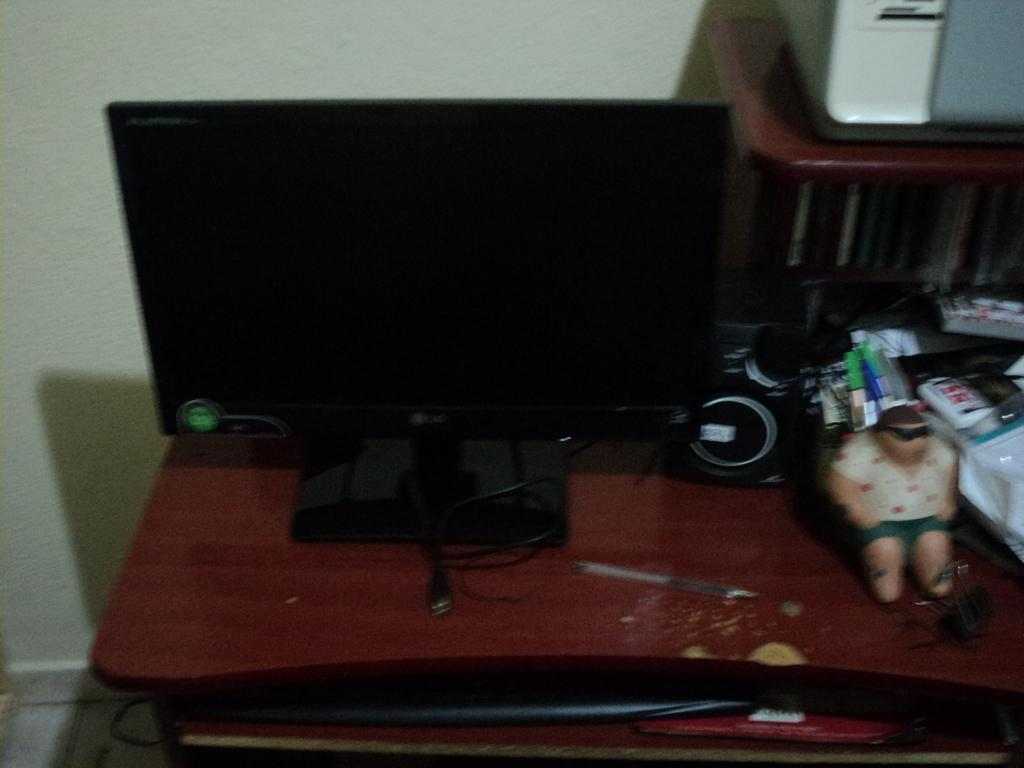What electronic device can be seen in the image? There is a monitor in the image. What is another device that can be seen in the image? There is a speaker in the image. What is the surface on which the monitor and speaker are placed? There are other objects on top of a table in the image. What is behind the table in the image? The table is placed in front of a wall. What type of sticks are used to create the value of the home in the image? There is no mention of sticks or the value of a home in the image. The image only features a monitor, a speaker, and objects on a table in front of a wall. 